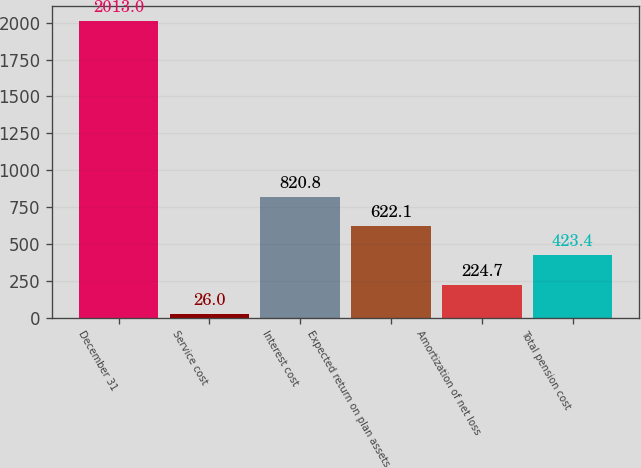Convert chart. <chart><loc_0><loc_0><loc_500><loc_500><bar_chart><fcel>December 31<fcel>Service cost<fcel>Interest cost<fcel>Expected return on plan assets<fcel>Amortization of net loss<fcel>Total pension cost<nl><fcel>2013<fcel>26<fcel>820.8<fcel>622.1<fcel>224.7<fcel>423.4<nl></chart> 